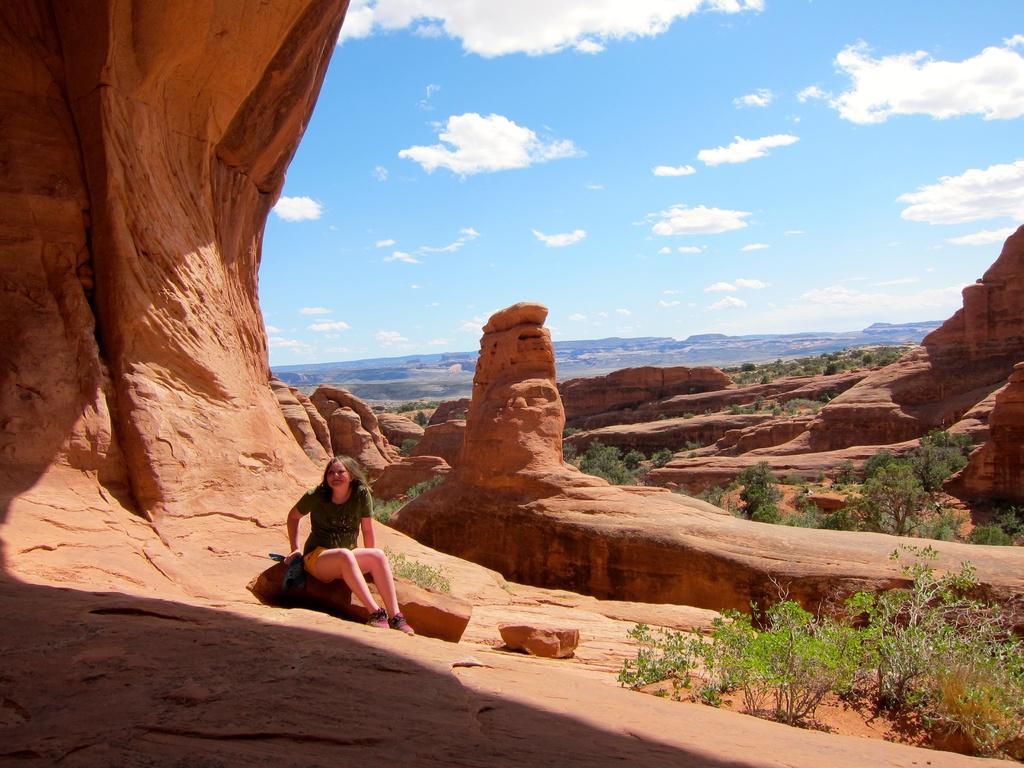Please provide a concise description of this image. In this picture we can see a girl sitting on a rock, trees, rocks, mountains and in the background we can see the sky with clouds. 